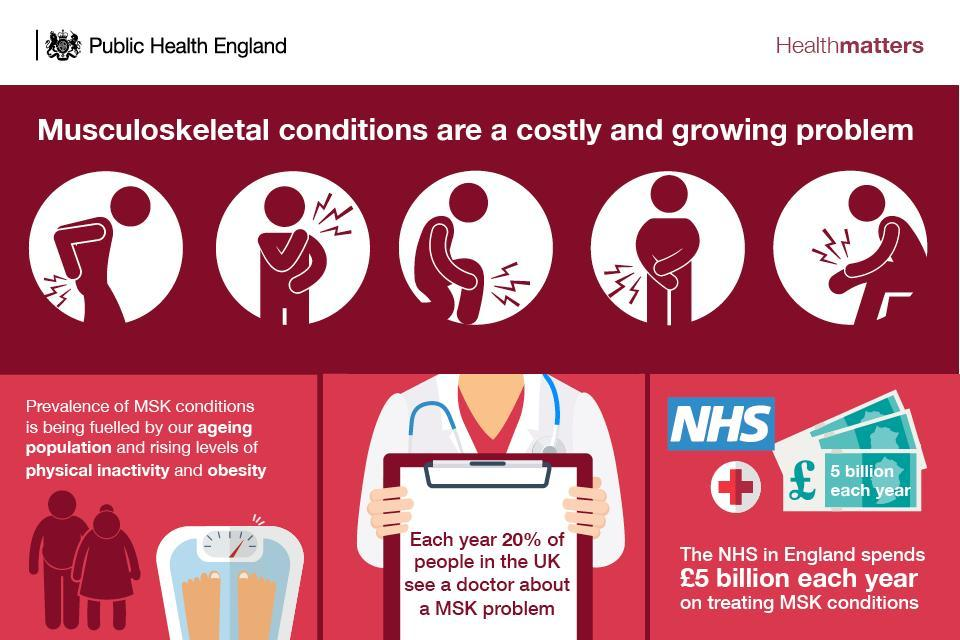How many images of money are in this infographic?
Answer the question with a short phrase. 3 